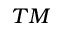Convert formula to latex. <formula><loc_0><loc_0><loc_500><loc_500>^ { T M }</formula> 